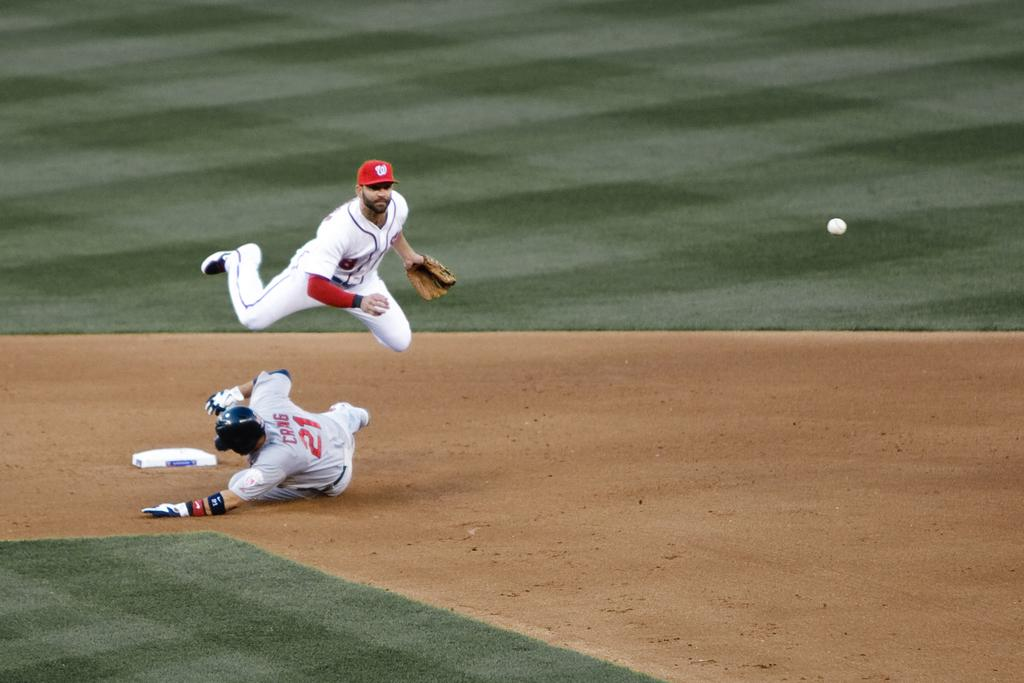Provide a one-sentence caption for the provided image. A baseball player with the number 21 on his jersey is sliding to base while another one jumps in the air. 